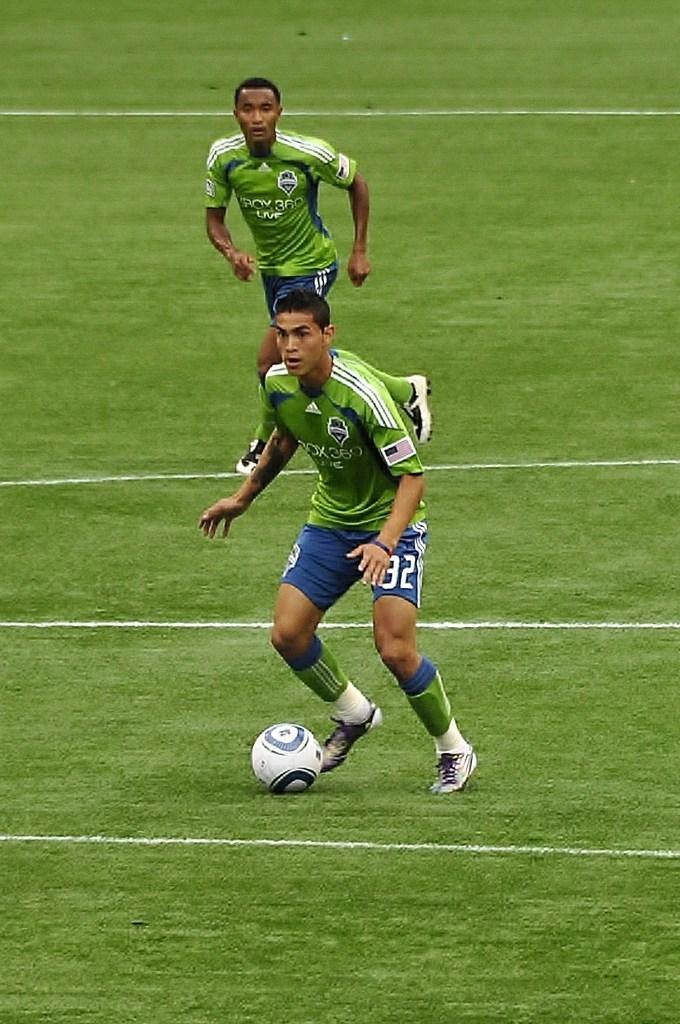Please provide a concise description of this image. In this picture we can see two players playing with a ball in a playground. 